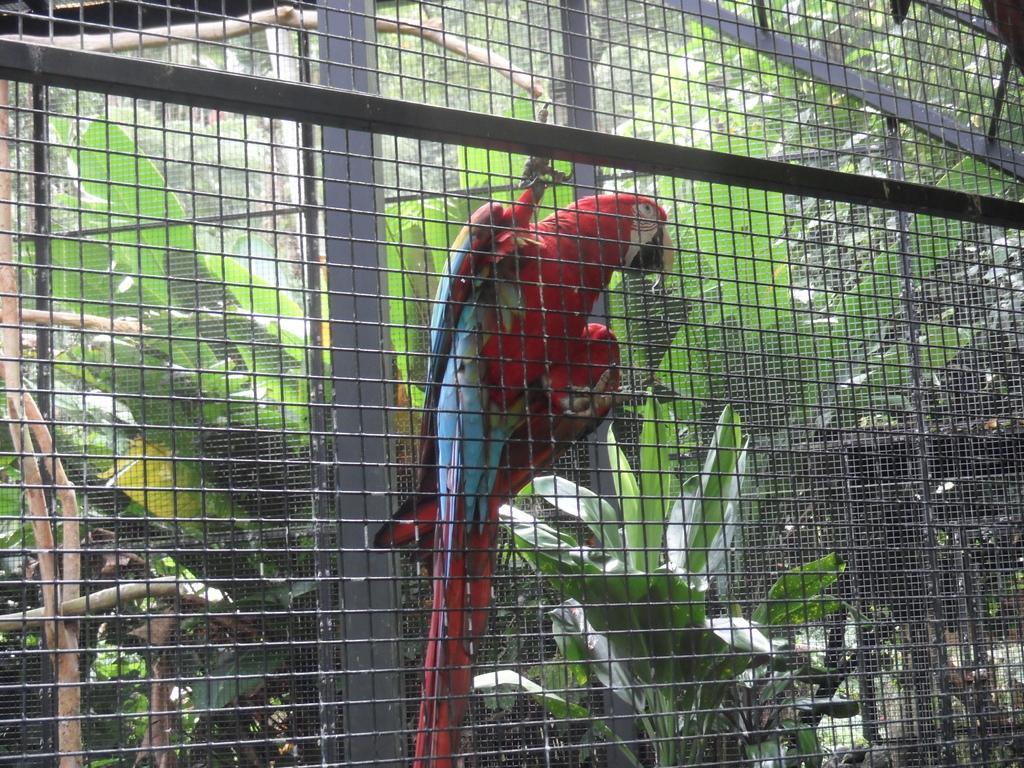Can you describe this image briefly? In this image I can see the bird inside the cage and the bird is in blue and red color. In the background I can see few plants in green color. 